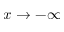Convert formula to latex. <formula><loc_0><loc_0><loc_500><loc_500>x \to - \infty</formula> 